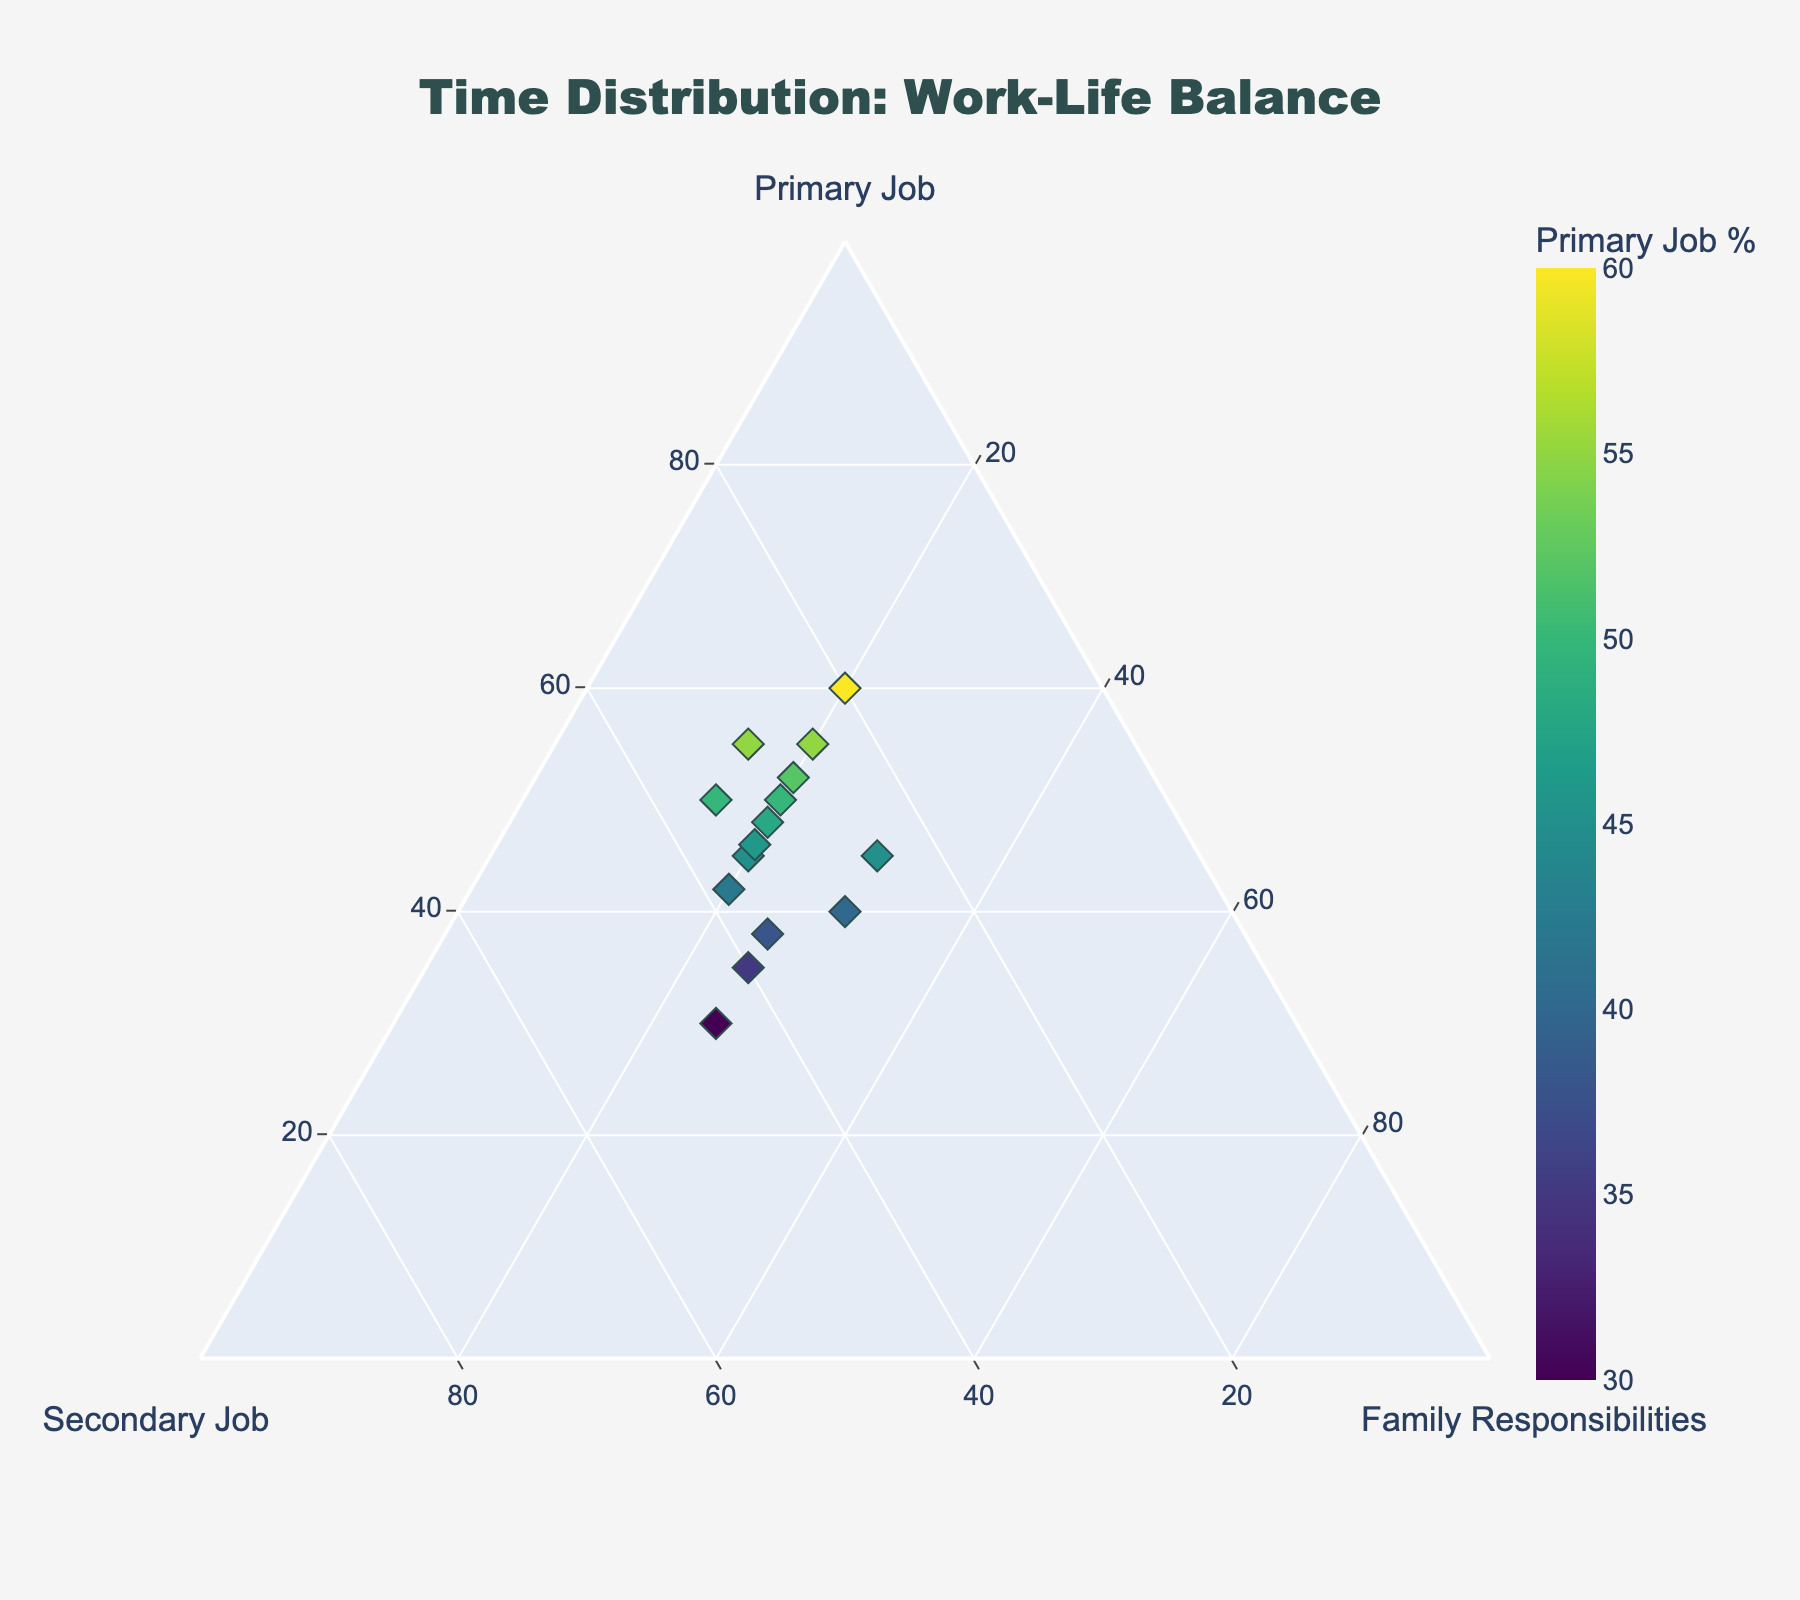What's the title of the figure? The title is displayed at the top center of the figure in a large font and reads "Time Distribution: Work-Life Balance".
Answer: Time Distribution: Work-Life Balance How many data points are shown in the figure? There are markers placed within the ternary plot. Counting these markers indicates the number of data points present.
Answer: 15 What is the percentage range for the Primary Job represented by the marker colors? The color bar provides a legend for the markers, indicating the percentage range. The legend starts at the lowest value and ends at the highest value.
Answer: 30% to 60% Which axis is titled "Family Responsibilities"? Each of the three axes in the ternary plot has a title. By looking at the figure, we locate "Family Responsibilities" along one of the borders of the triangle.
Answer: The c axis What is the sum of Primary Job and Secondary Job percentages for the data point with the highest Family Responsibilities? By examining the data points, the one with the highest Family Responsibilities is highlighted. Looking at the corresponding percentages for Primary and Secondary Job allows us to sum them up. The mentioned data point has 40% for Primary Job and 30% for Secondary Job. Adding these we get 40 + 30 = 70.
Answer: 70% Are there any data points with equal percentages for Primary Job and Secondary Job? Inspecting each data point's hover text reveals the data points' percentages. We compare the percentages of Primary Job and Secondary Job to see if they are identical for any point. No specific equal pair is found in the provided data set.
Answer: No Which data point has the lowest percentage of Primary Job, and what are its percentages for Secondary Job and Family Responsibilities? The hover text provides clear values for each data point. By identifying the one with the lowest Primary Job percentage (30%), we read off the values for the other two categories. This data point has 45% for Secondary Job and 25% for Family Responsibilities.
Answer: 45% Secondary Job, 25% Family Responsibilities Is there a visible clustering of any data points in the figure, and if so, around which axis? Visual clustering can be seen when multiple markers are closely grouped within the plot. By observing where this clustering occurs, we identify that many points are near the Primary Job axis.
Answer: Near the Primary Job axis How does the marker size impact the interpretation of individual data points? Marker size often represents another variable in scatter plots, but in this figure, all markers appear to be of a uniform size, indicating no additional data interpretation based on size is necessary.
Answer: Marker size does not impact interpretation What is the average Primary Job percentage for all data points? Summing up all Primary Job percentages from the data and dividing by the number of data points provides the average. Sum(50 + 45 + 55 + 40 + 60 + 35 + 45 + 50 + 30 + 55 + 42 + 48 + 38 + 52 + 46) = 691, and dividing by 15 gives approximately 46.1.
Answer: 46.1% 